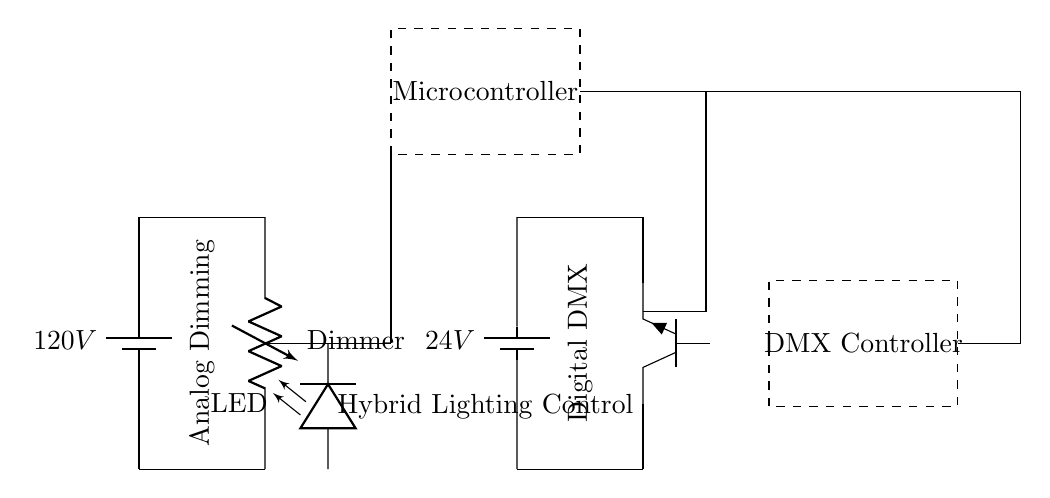What is the voltage of the analog dimming section? The analog dimming section has a voltage of 120V, which is indicated next to the battery in that section of the circuit.
Answer: 120V What is the role of the microcontroller in this circuit? The microcontroller is responsible for processing signals and controlling the DMX protocol within the hybrid lighting system, as indicated by its label in the diagram.
Answer: Control signals What type of dimmer is used in the analog section? The dimmer used in the analog section is labeled simply as "Dimmer," which denotes a variable resistor that adjusts the brightness of the connected LED.
Answer: Dimmer What is the voltage of the digital DMX section? The digital DMX section operates at a voltage of 24V, shown next to the battery that powers this part of the circuit.
Answer: 24V Explain the connection between the dimmer and the microcontroller. The connection between the dimmer and the microcontroller is established through a series of wires as shown in the circuit. The dimmer is connected to a point leading to the microcontroller, allowing the microcontroller to receive input signals based on the dimming level. This connection is essential for the integration of analog control into the digital system.
Answer: Microcontroller input What does the dashed rectangle represent in the circuit? The dashed rectangle represents the DMX controller, which is an important component that interfaces with the digital aspects of the lighting system, allowing for control via DMX protocols. This is visually indicated by the rectangle and the label inside it.
Answer: DMX Controller How does the LED connect to the dimmer? The LED is connected to the dimmer through a wire that leads directly from the output of the dimmer to the LED, allowing the dimmer to control the brightness of the LED based on the setting adjusted by the user. This shows how the analog part of the system influences the lighting effect.
Answer: Direct connection 